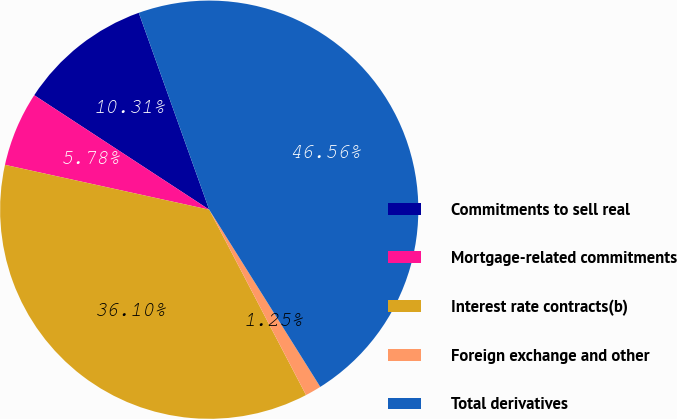Convert chart to OTSL. <chart><loc_0><loc_0><loc_500><loc_500><pie_chart><fcel>Commitments to sell real<fcel>Mortgage-related commitments<fcel>Interest rate contracts(b)<fcel>Foreign exchange and other<fcel>Total derivatives<nl><fcel>10.31%<fcel>5.78%<fcel>36.1%<fcel>1.25%<fcel>46.56%<nl></chart> 